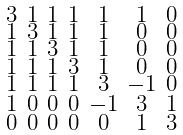Convert formula to latex. <formula><loc_0><loc_0><loc_500><loc_500>\begin{smallmatrix} 3 & 1 & 1 & 1 & 1 & 1 & 0 \\ 1 & 3 & 1 & 1 & 1 & 0 & 0 \\ 1 & 1 & 3 & 1 & 1 & 0 & 0 \\ 1 & 1 & 1 & 3 & 1 & 0 & 0 \\ 1 & 1 & 1 & 1 & 3 & - 1 & 0 \\ 1 & 0 & 0 & 0 & - 1 & 3 & 1 \\ 0 & 0 & 0 & 0 & 0 & 1 & 3 \end{smallmatrix}</formula> 